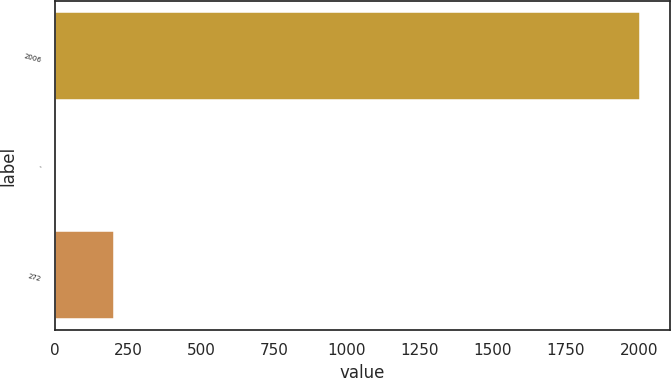Convert chart to OTSL. <chart><loc_0><loc_0><loc_500><loc_500><bar_chart><fcel>2006<fcel>-<fcel>272<nl><fcel>2005<fcel>1.5<fcel>201.85<nl></chart> 